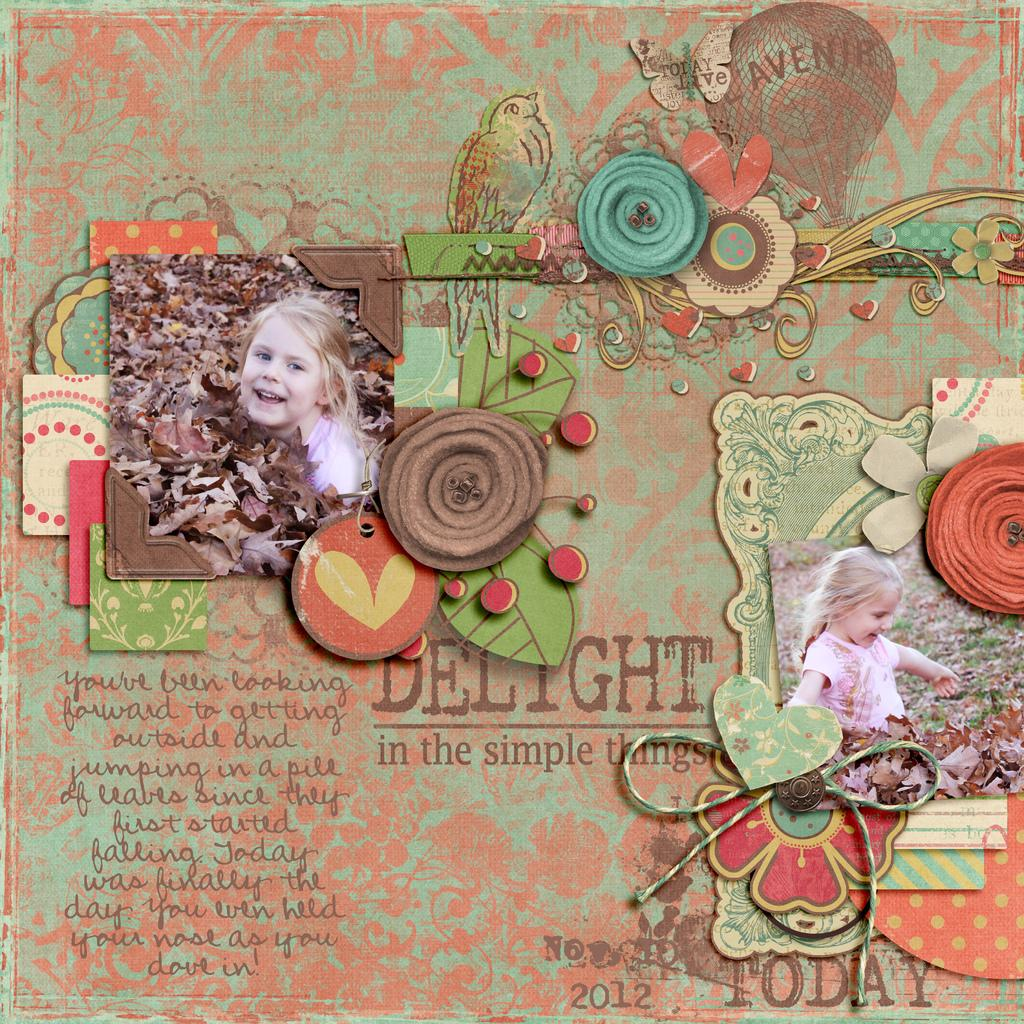What is the main object in the image? There is a card in the image. Who are the people featured on the card? There are photos of two people on the card. What can be seen in the background of the image? There are leaves visible in the image. What animals are present in the image? There is a bird and a butterfly in the image. What else is on the card besides the photos of people? There is some text on the card. Can you tell me how many planes are flying in the image? There are no planes visible in the image; it features a card with photos of people, text, and images of a bird and a butterfly. What is the cause of death for the person in the image? There is no indication of death or any person in the image; it features a card with photos of two people, text, and images of a bird and a butterfly. 